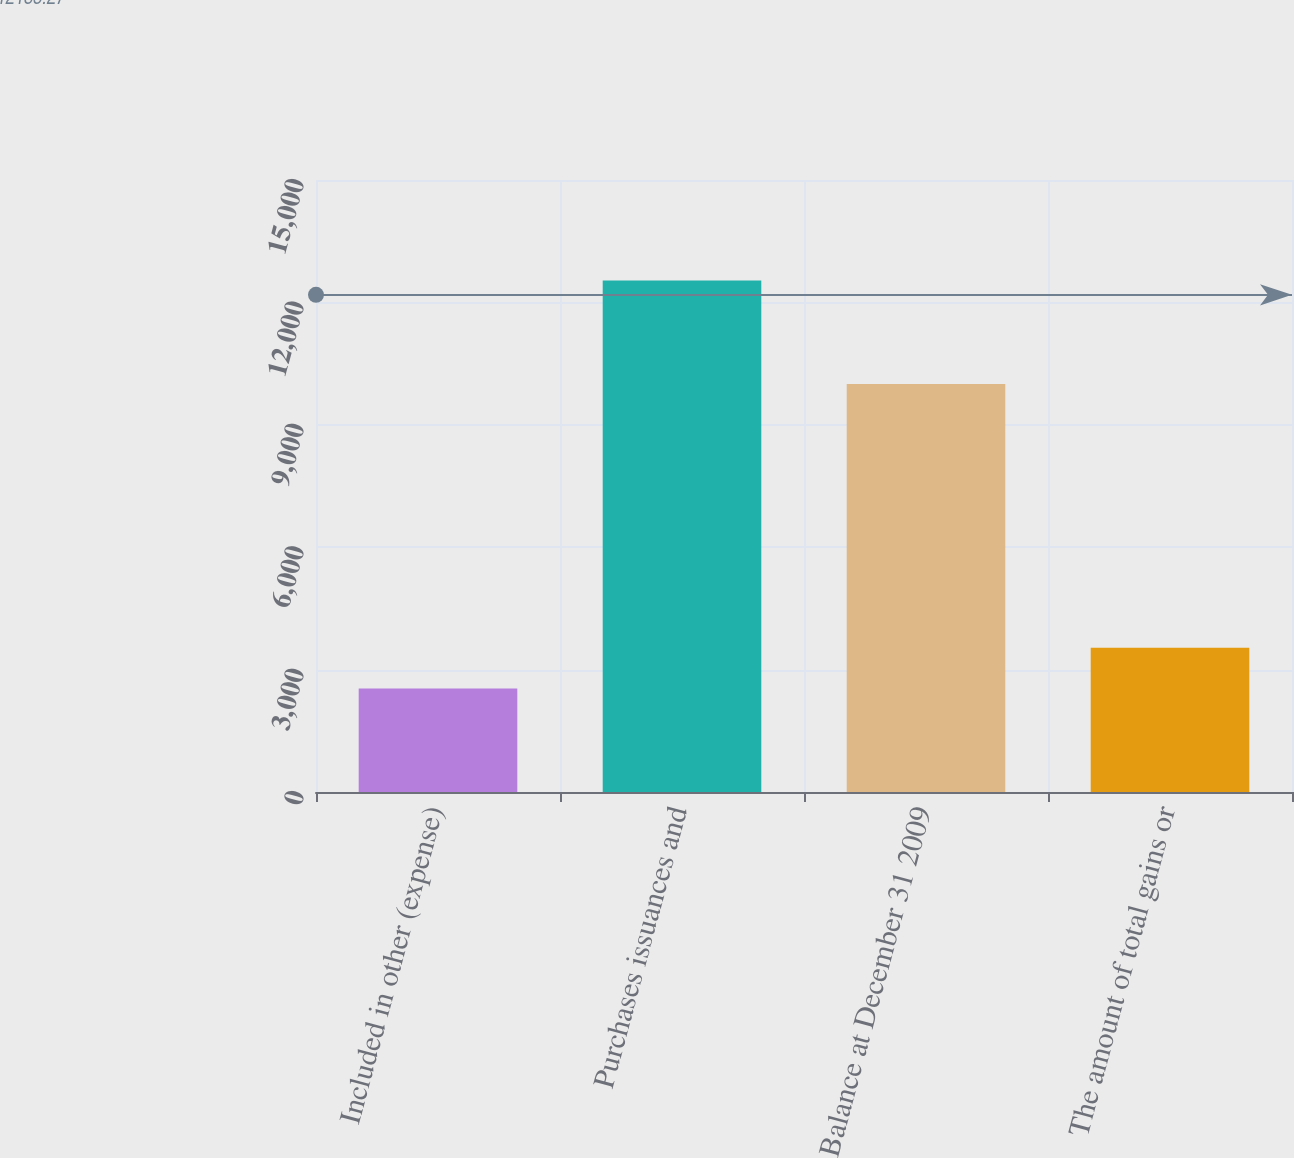<chart> <loc_0><loc_0><loc_500><loc_500><bar_chart><fcel>Included in other (expense)<fcel>Purchases issuances and<fcel>Balance at December 31 2009<fcel>The amount of total gains or<nl><fcel>2538<fcel>12536<fcel>9998<fcel>3537.8<nl></chart> 